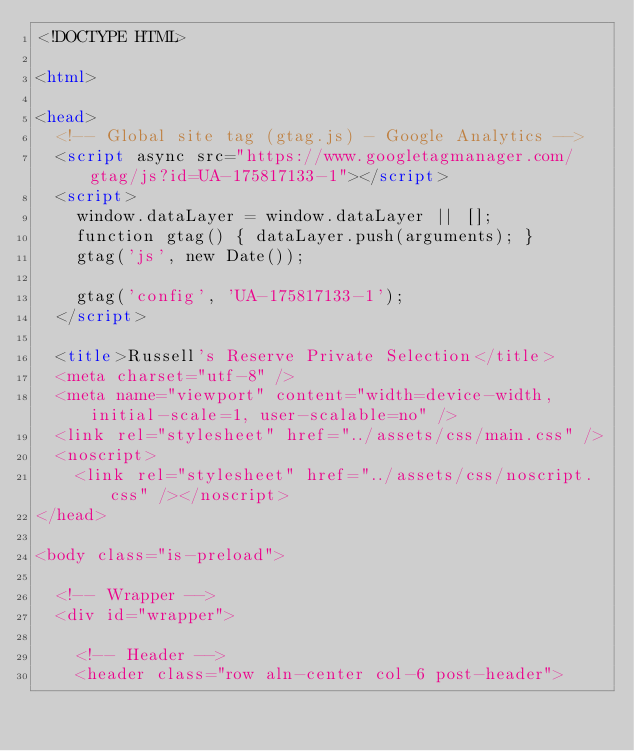<code> <loc_0><loc_0><loc_500><loc_500><_HTML_><!DOCTYPE HTML>

<html>

<head>
	<!-- Global site tag (gtag.js) - Google Analytics -->
	<script async src="https://www.googletagmanager.com/gtag/js?id=UA-175817133-1"></script>
	<script>
		window.dataLayer = window.dataLayer || [];
		function gtag() { dataLayer.push(arguments); }
		gtag('js', new Date());

		gtag('config', 'UA-175817133-1');
	</script>

	<title>Russell's Reserve Private Selection</title>
	<meta charset="utf-8" />
	<meta name="viewport" content="width=device-width, initial-scale=1, user-scalable=no" />
	<link rel="stylesheet" href="../assets/css/main.css" />
	<noscript>
		<link rel="stylesheet" href="../assets/css/noscript.css" /></noscript>
</head>

<body class="is-preload">

	<!-- Wrapper -->
	<div id="wrapper">

		<!-- Header -->
		<header class="row aln-center col-6 post-header"></code> 